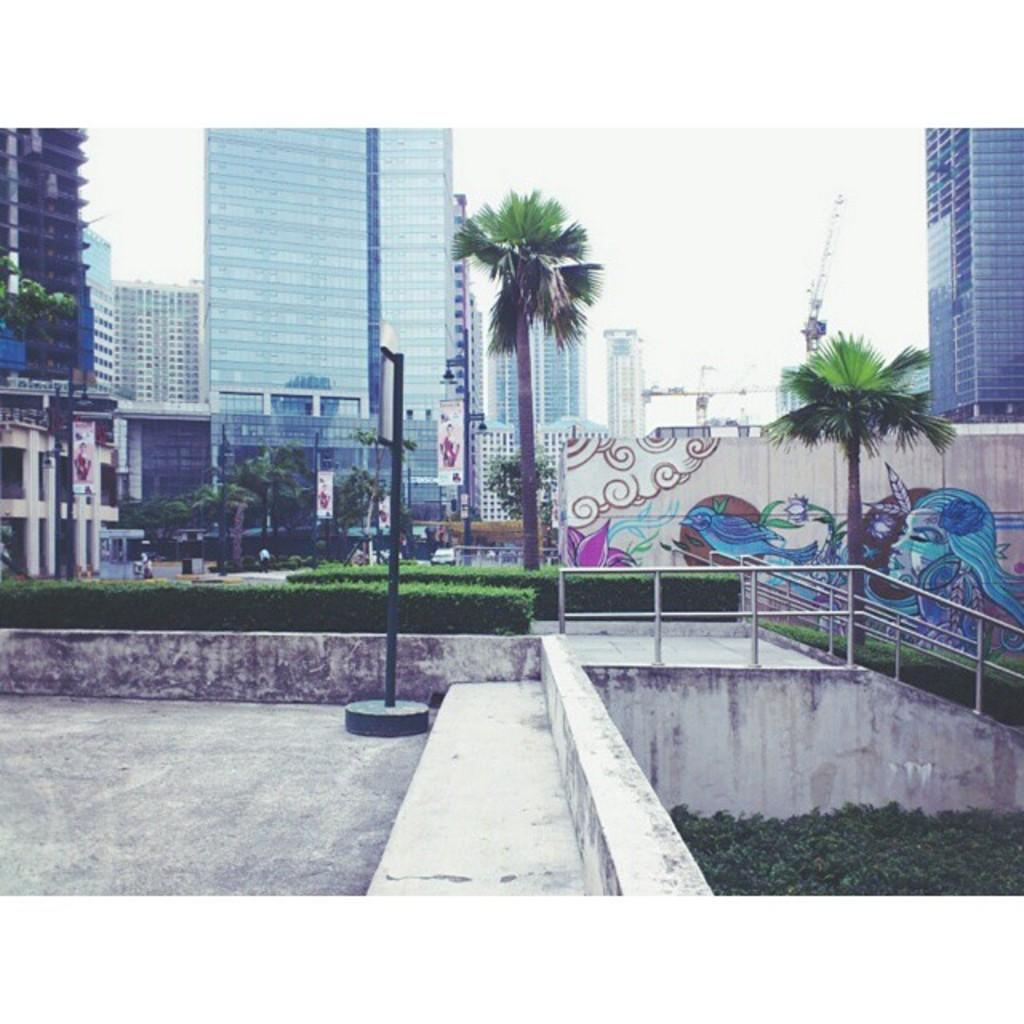What is located at the front of the image? There is a pole in the front of the image. What can be seen at the right bottom of the image? There are plants at the right bottom of the image. What is visible in the background of the image? Buildings, trees, shrubs, hoardings, and the sky are visible in the background of the image. What type of advertisement can be seen on the cow in the image? There is no cow present in the image, and therefore no advertisement can be observed on it. What does the mouth of the plant look like in the image? The image does not depict a plant with a mouth, as plants do not have mouths. 